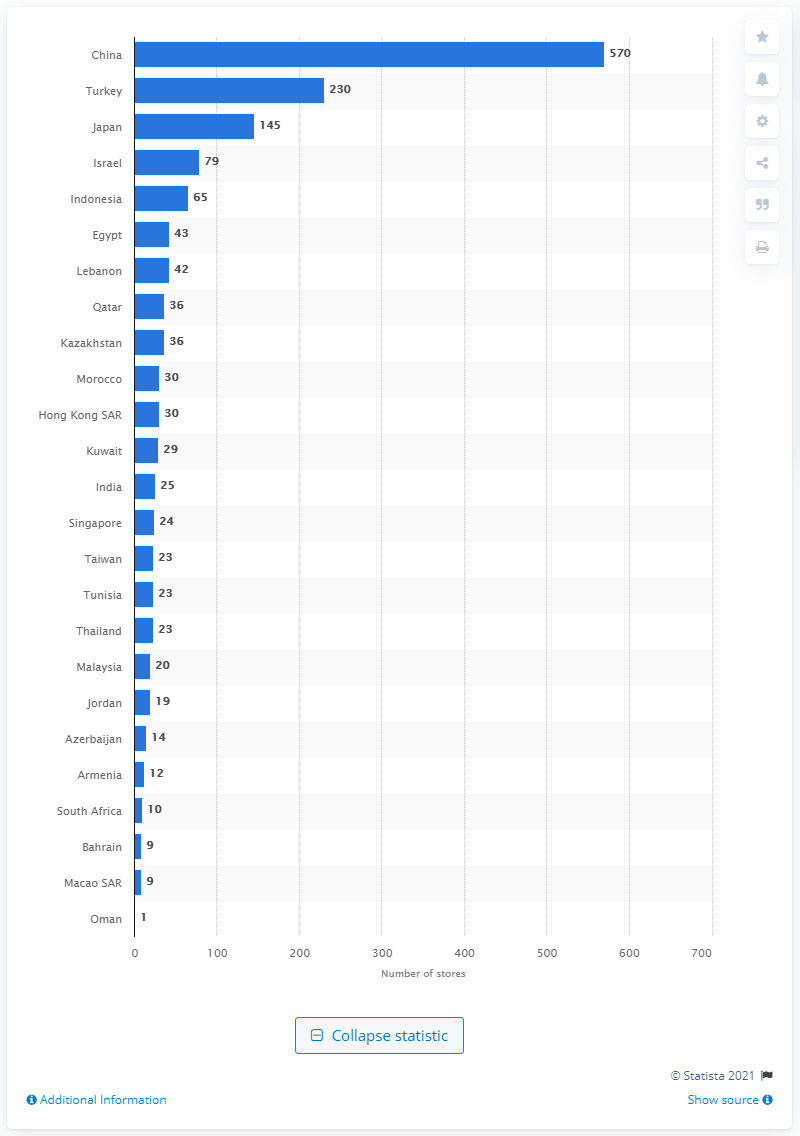List a handful of essential elements in this visual. As of January 31, 2020, there were 570 Inditex stores in China. 